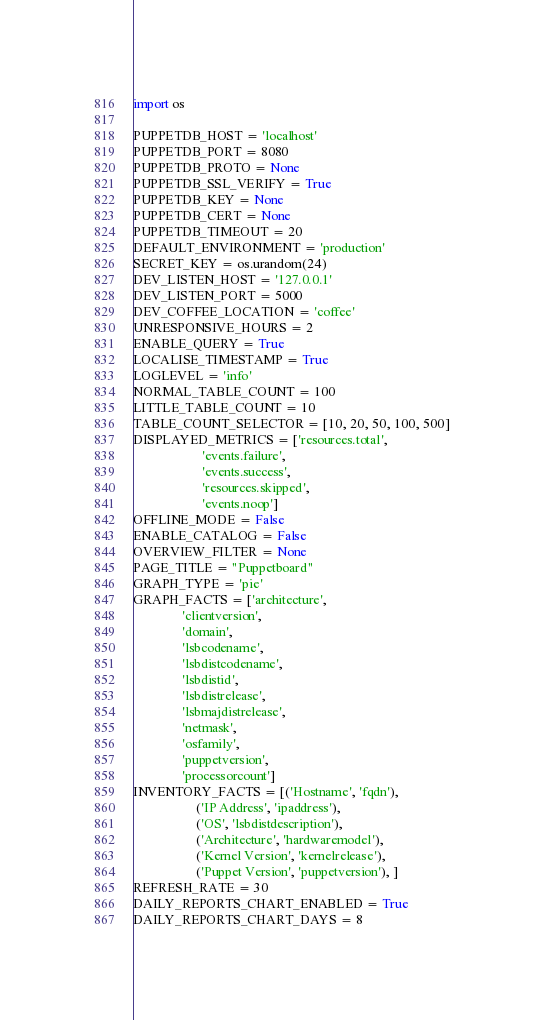<code> <loc_0><loc_0><loc_500><loc_500><_Python_>import os

PUPPETDB_HOST = 'localhost'
PUPPETDB_PORT = 8080
PUPPETDB_PROTO = None
PUPPETDB_SSL_VERIFY = True
PUPPETDB_KEY = None
PUPPETDB_CERT = None
PUPPETDB_TIMEOUT = 20
DEFAULT_ENVIRONMENT = 'production'
SECRET_KEY = os.urandom(24)
DEV_LISTEN_HOST = '127.0.0.1'
DEV_LISTEN_PORT = 5000
DEV_COFFEE_LOCATION = 'coffee'
UNRESPONSIVE_HOURS = 2
ENABLE_QUERY = True
LOCALISE_TIMESTAMP = True
LOGLEVEL = 'info'
NORMAL_TABLE_COUNT = 100
LITTLE_TABLE_COUNT = 10
TABLE_COUNT_SELECTOR = [10, 20, 50, 100, 500]
DISPLAYED_METRICS = ['resources.total',
                     'events.failure',
                     'events.success',
                     'resources.skipped',
                     'events.noop']
OFFLINE_MODE = False
ENABLE_CATALOG = False
OVERVIEW_FILTER = None
PAGE_TITLE = "Puppetboard"
GRAPH_TYPE = 'pie'
GRAPH_FACTS = ['architecture',
               'clientversion',
               'domain',
               'lsbcodename',
               'lsbdistcodename',
               'lsbdistid',
               'lsbdistrelease',
               'lsbmajdistrelease',
               'netmask',
               'osfamily',
               'puppetversion',
               'processorcount']
INVENTORY_FACTS = [('Hostname', 'fqdn'),
                   ('IP Address', 'ipaddress'),
                   ('OS', 'lsbdistdescription'),
                   ('Architecture', 'hardwaremodel'),
                   ('Kernel Version', 'kernelrelease'),
                   ('Puppet Version', 'puppetversion'), ]
REFRESH_RATE = 30
DAILY_REPORTS_CHART_ENABLED = True
DAILY_REPORTS_CHART_DAYS = 8
</code> 